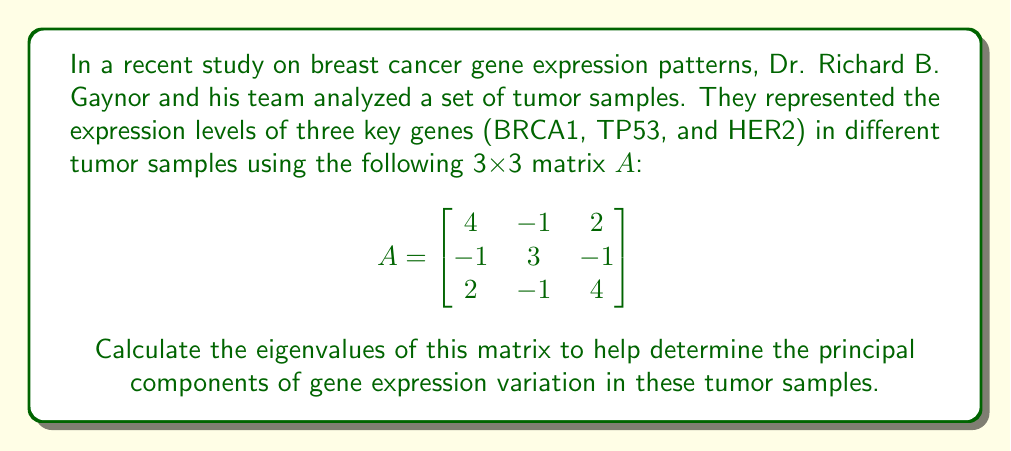Give your solution to this math problem. To find the eigenvalues of matrix A, we need to solve the characteristic equation:

$$det(A - \lambda I) = 0$$

Where $\lambda$ represents the eigenvalues and I is the 3x3 identity matrix.

Step 1: Subtract $\lambda I$ from A:

$$A - \lambda I = \begin{bmatrix}
4-\lambda & -1 & 2 \\
-1 & 3-\lambda & -1 \\
2 & -1 & 4-\lambda
\end{bmatrix}$$

Step 2: Calculate the determinant:

$$det(A - \lambda I) = (4-\lambda)[(3-\lambda)(4-\lambda) - 1] - (-1)[(-1)(4-\lambda) - 2(-1)] + 2[(-1)(-1) - (3-\lambda)(2)]$$

Step 3: Expand and simplify:

$$det(A - \lambda I) = (4-\lambda)(12-7\lambda+\lambda^2) + (4-\lambda-2) + 2(1-6+2\lambda)$$
$$= 48-28\lambda+4\lambda^2-12\lambda+7\lambda^2-\lambda^3 + 2-\lambda + 2-12+4\lambda$$
$$= -\lambda^3 + 11\lambda^2 - 37\lambda + 40$$

Step 4: Set the characteristic equation to zero:

$$-\lambda^3 + 11\lambda^2 - 37\lambda + 40 = 0$$

Step 5: Solve the equation. This cubic equation can be factored as:

$$-(\lambda - 5)(\lambda - 3)(\lambda - 3) = 0$$

Therefore, the eigenvalues are:

$\lambda_1 = 5$
$\lambda_2 = 3$ (with algebraic multiplicity 2)
Answer: The eigenvalues of the matrix A are:
$\lambda_1 = 5$, $\lambda_2 = 3$ (with algebraic multiplicity 2) 